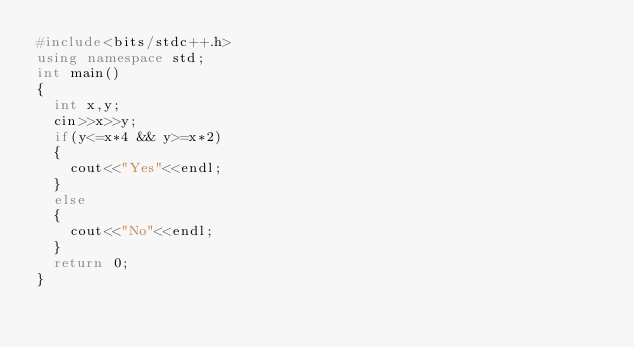<code> <loc_0><loc_0><loc_500><loc_500><_C++_>#include<bits/stdc++.h>
using namespace std;
int main()
{
  int x,y;
  cin>>x>>y;
  if(y<=x*4 && y>=x*2)
  {
    cout<<"Yes"<<endl;
  }
  else
  {
    cout<<"No"<<endl;
  }
  return 0;
}</code> 